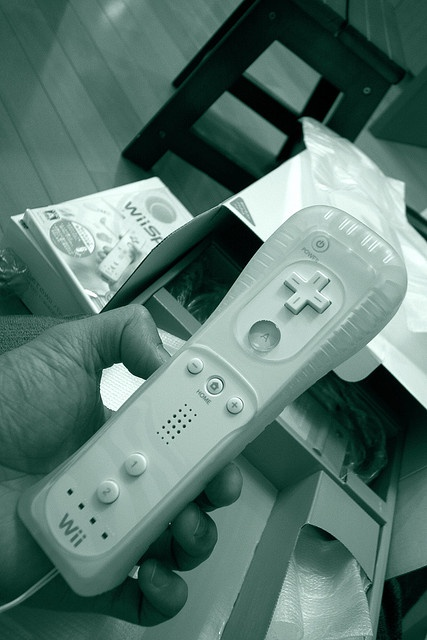Describe the objects in this image and their specific colors. I can see remote in teal, darkgray, and lightblue tones, people in teal, black, and darkgreen tones, chair in teal, black, and darkgreen tones, book in teal, ivory, darkgray, and lightblue tones, and book in teal, ivory, and gray tones in this image. 